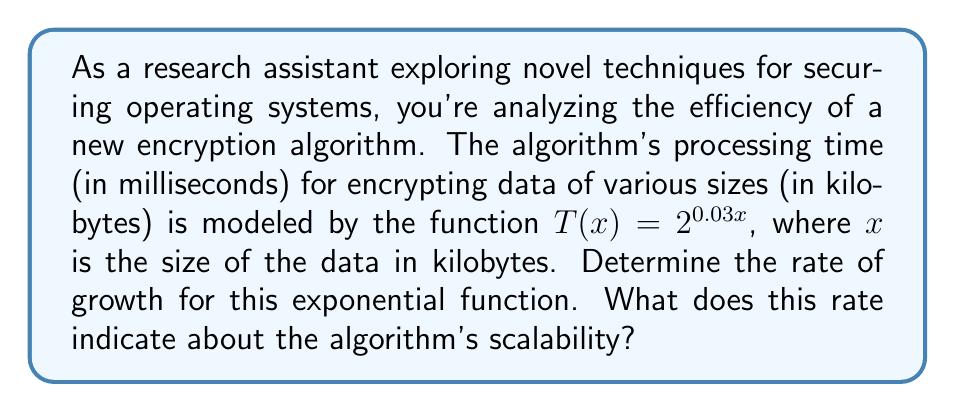Can you answer this question? To determine the rate of growth for this exponential function, we need to analyze its base and exponent:

1) The given function is $T(x) = 2^{0.03x}$

2) In general, an exponential function is of the form $f(x) = a \cdot b^x$, where $a$ is a constant and $b$ is the base.

3) In our case, we can rewrite the function as:
   $T(x) = 1 \cdot (2^{0.03})^x$

4) Let's calculate $2^{0.03}$:
   $2^{0.03} \approx 1.0210$

5) So, our function can be written as:
   $T(x) \approx 1.0210^x$

6) The rate of growth for an exponential function is determined by its base. In this case, the base is approximately 1.0210.

7) This means that for each increase of 1 unit in $x$ (1 kilobyte of data), the processing time multiplies by a factor of about 1.0210.

8) We can interpret this as a 2.10% increase in processing time for each additional kilobyte of data.

9) To understand the scalability:
   - If the base were exactly 1, the function would be constant (no growth).
   - A base greater than 1 (as in this case) indicates exponential growth.
   - The closer the base is to 1, the slower the exponential growth.

10) A growth rate of 2.10% per kilobyte suggests that while the algorithm does scale exponentially, the growth is relatively slow for small increases in data size.
Answer: The rate of growth for the exponential function is approximately 1.0210, or a 2.10% increase per kilobyte. This indicates that the algorithm scales exponentially, but at a relatively slow rate for small data size increases, suggesting moderate scalability for the encryption algorithm. 